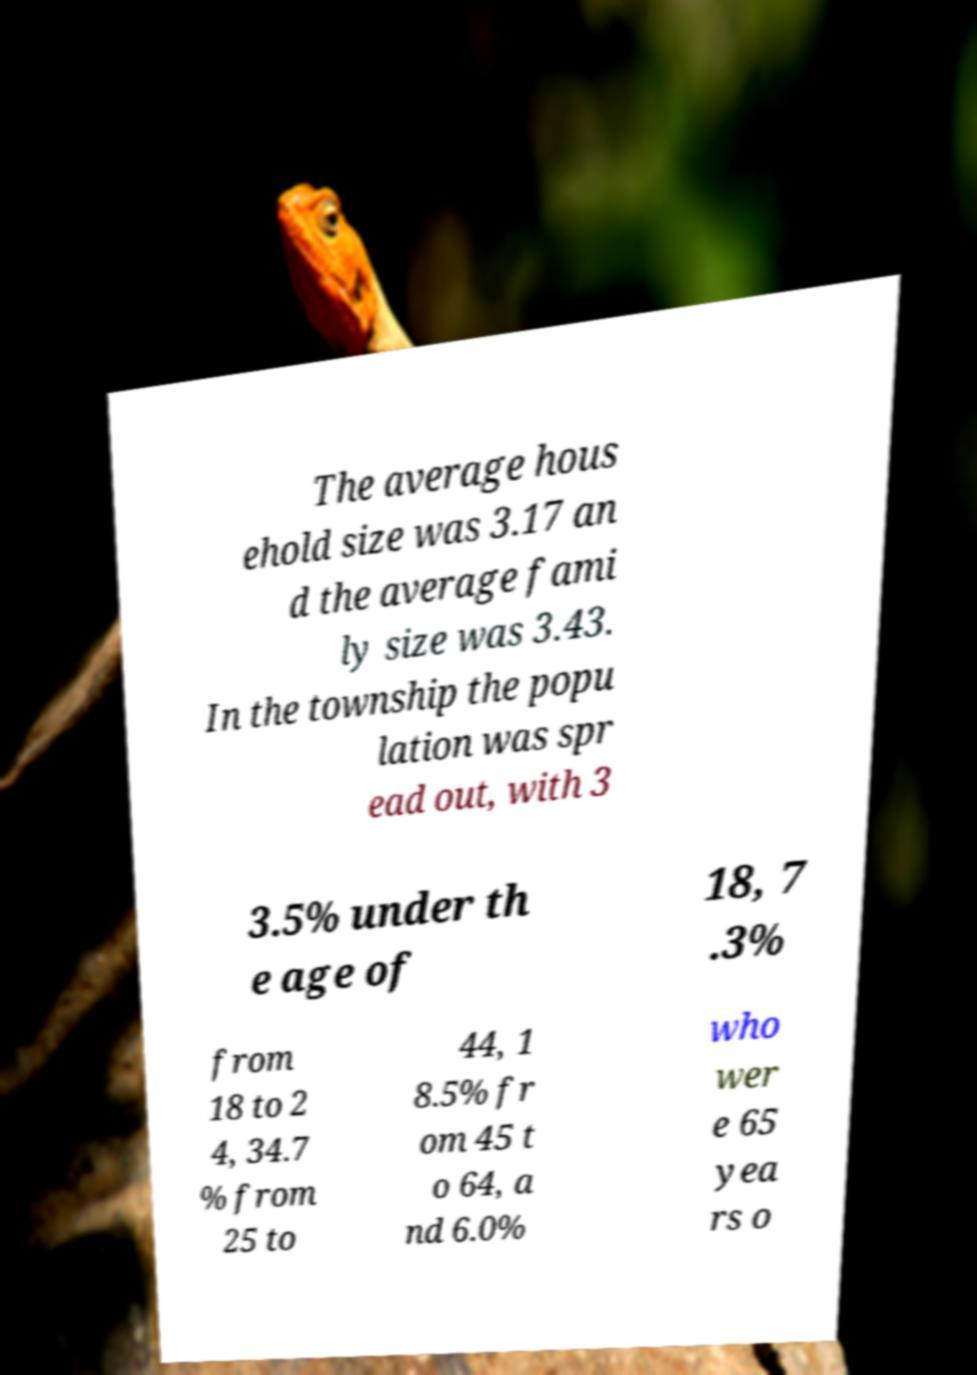I need the written content from this picture converted into text. Can you do that? The average hous ehold size was 3.17 an d the average fami ly size was 3.43. In the township the popu lation was spr ead out, with 3 3.5% under th e age of 18, 7 .3% from 18 to 2 4, 34.7 % from 25 to 44, 1 8.5% fr om 45 t o 64, a nd 6.0% who wer e 65 yea rs o 